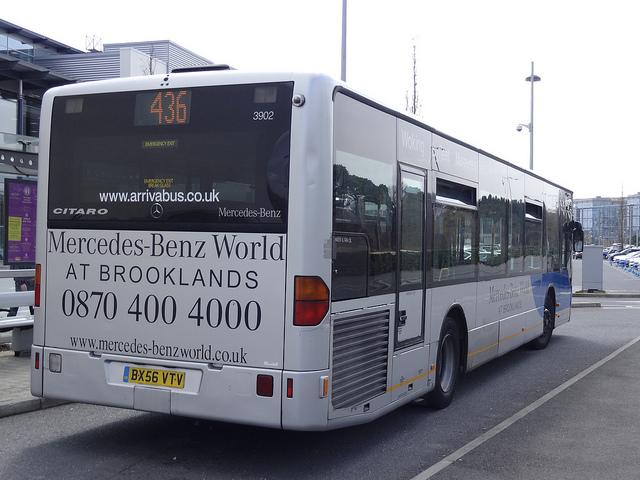Is this a Mercedes-Benz bus?
Give a very brief answer. Yes. Could this be in the USA?
Give a very brief answer. No. What does the license plate say?
Write a very short answer. Bx56vtv. What phone number is on the truck?
Give a very brief answer. 0870 400 4000. What number is above the license plate?
Write a very short answer. 0870 400 4000. What number is on the bus?
Concise answer only. 436. What is the bus number?
Quick response, please. 436. Is this person driving safely?
Be succinct. Yes. What is the color of the free shuttle bus?
Keep it brief. White. What is the license plate number?
Short answer required. Bx56 vtv. What bus line is closest to the sidewalk?
Keep it brief. Arriva bus. Are shuttle buses always free from this location?
Concise answer only. No. What does the back of the bus say?
Short answer required. Mercedes benz world. What color is the back of the bus?
Write a very short answer. White. Is this bus in need of cleaning?
Quick response, please. No. 